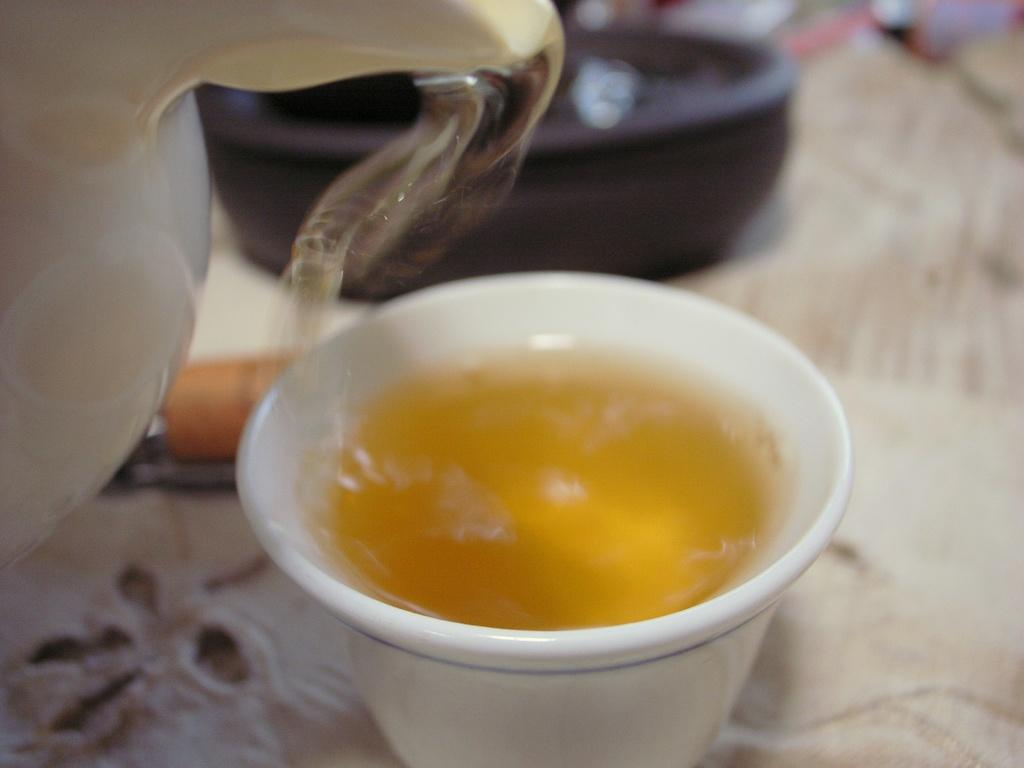What is inside the cup that is visible in the image? There is a drink in the cup in the image. What other container can be seen in the image? There is a jar in the image. What is on the table in the image? There is a bowl on a table in the image. How would you describe the background of the image? The background of the image is slightly blurred. What type of book is the person reading in the image? There is no person or book present in the image; it only features a cup with a drink, a jar, a bowl on a table, and a slightly blurred background. How many cattle are visible in the image? There are no cattle present in the image. 